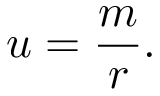<formula> <loc_0><loc_0><loc_500><loc_500>u = \frac { m } { r } .</formula> 